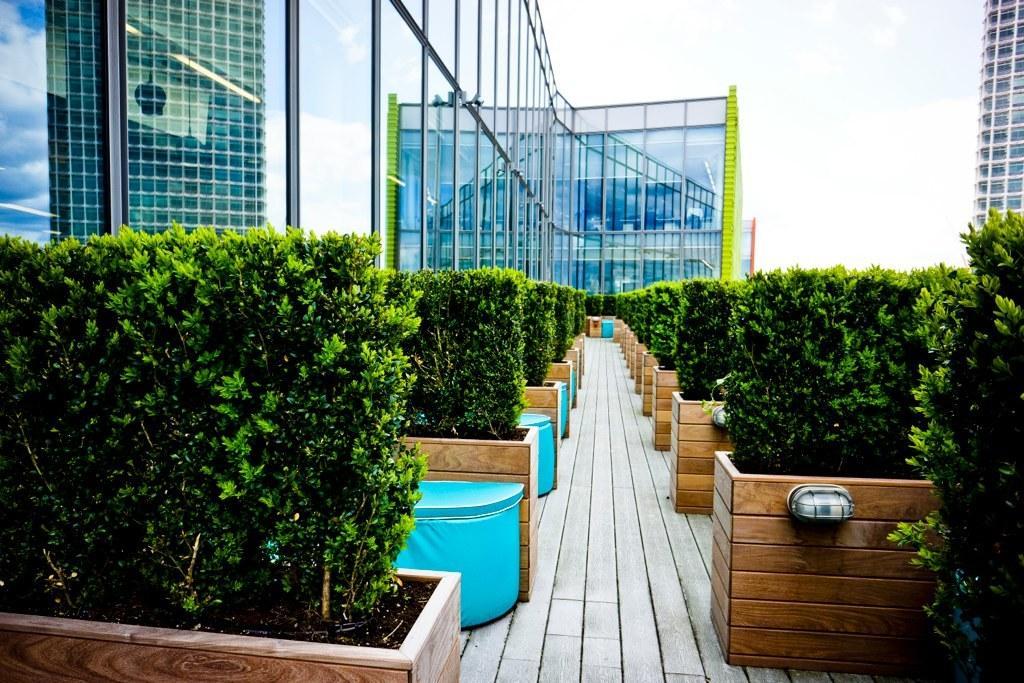Could you give a brief overview of what you see in this image? In this image we can see the plants in the wooden boxes. And we can see the buildings. And we can see the reflections on the glass. And we can see the sky at the top. 